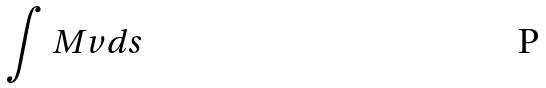Convert formula to latex. <formula><loc_0><loc_0><loc_500><loc_500>\int M v d s</formula> 